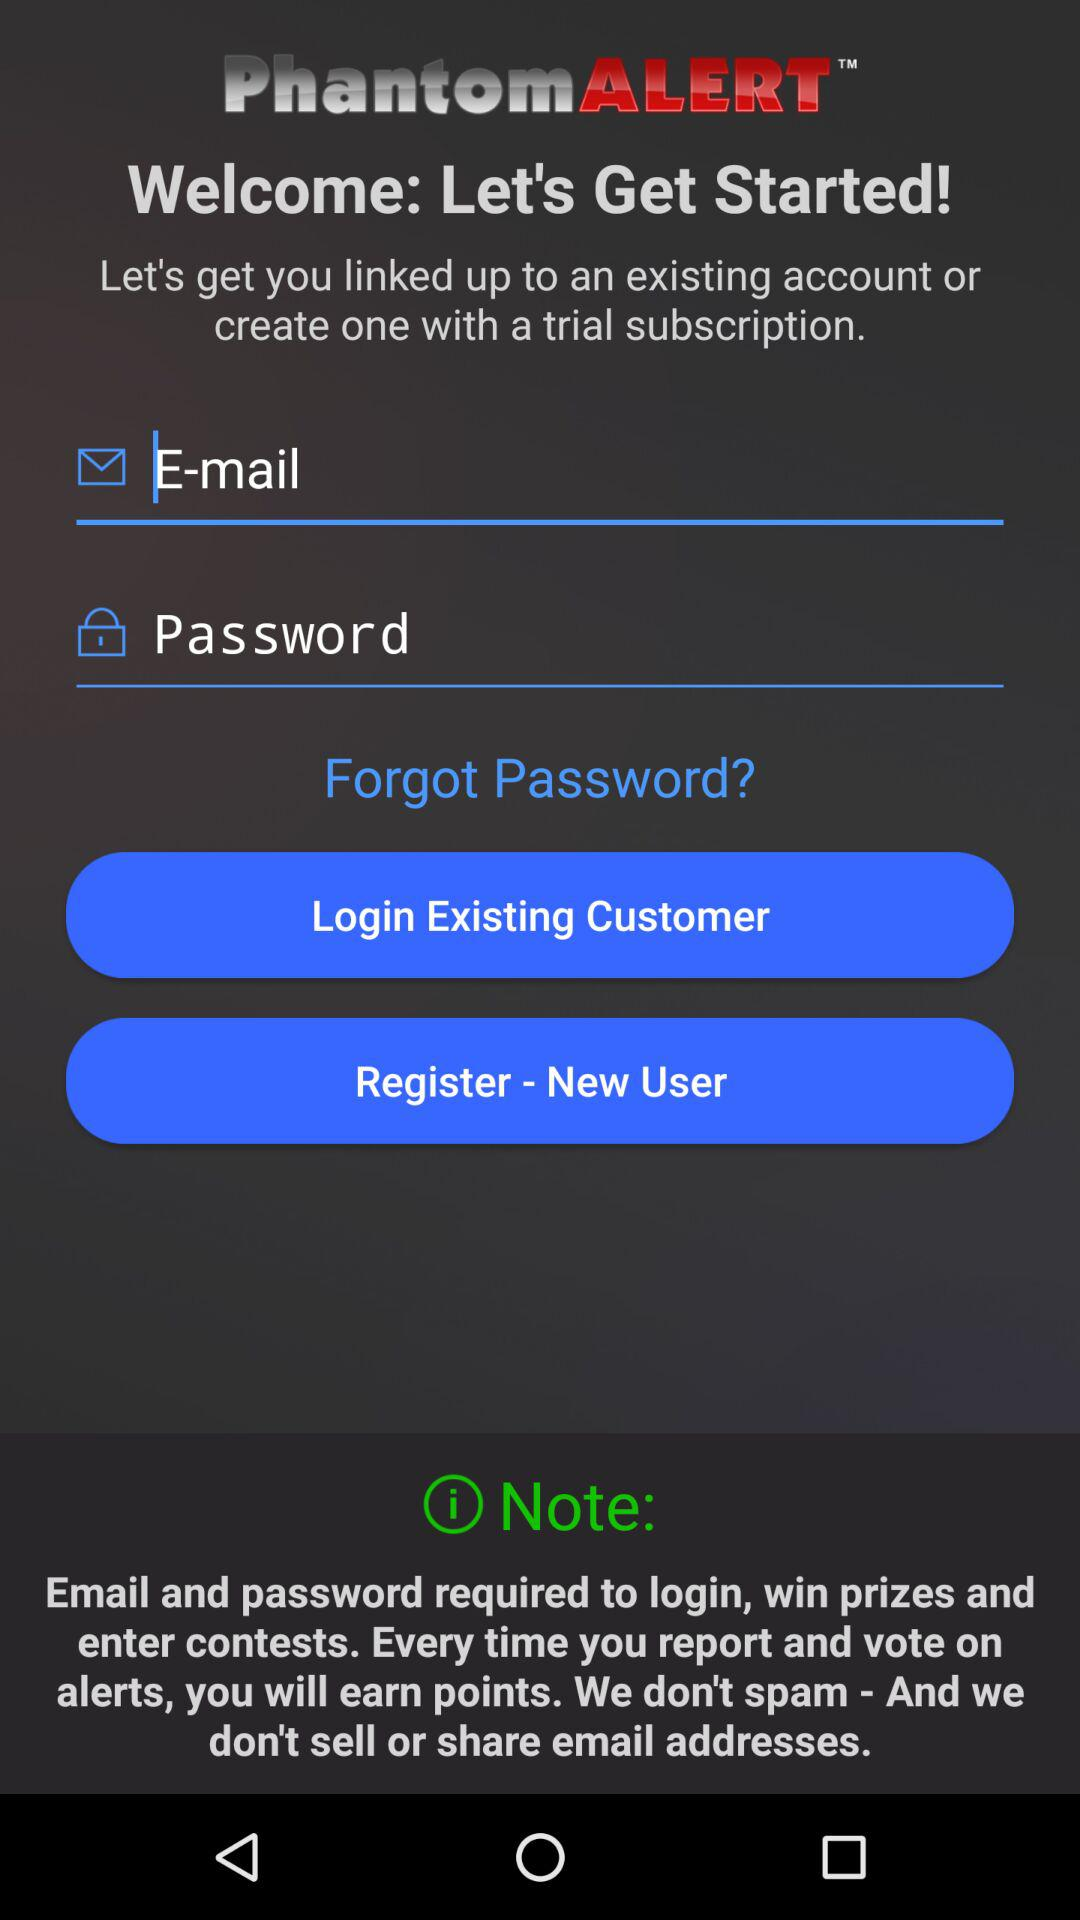What is the app name? The app name is "PhantomALERT". 